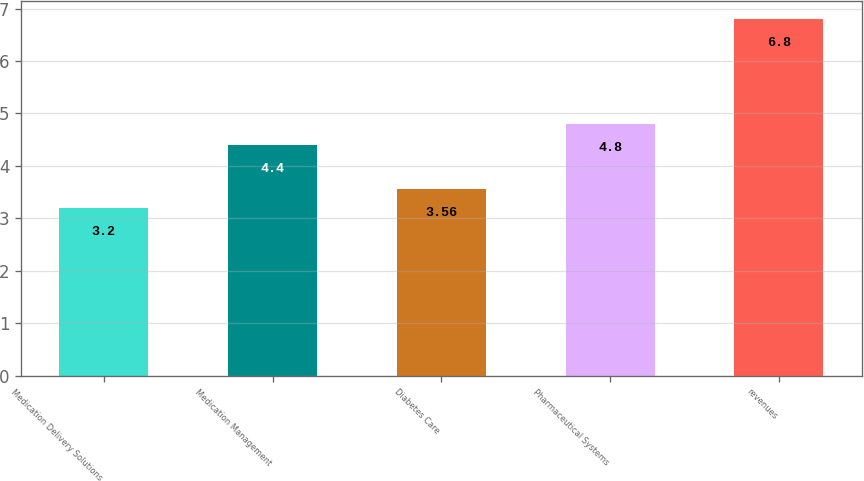<chart> <loc_0><loc_0><loc_500><loc_500><bar_chart><fcel>Medication Delivery Solutions<fcel>Medication Management<fcel>Diabetes Care<fcel>Pharmaceutical Systems<fcel>revenues<nl><fcel>3.2<fcel>4.4<fcel>3.56<fcel>4.8<fcel>6.8<nl></chart> 